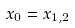Convert formula to latex. <formula><loc_0><loc_0><loc_500><loc_500>x _ { 0 } = x _ { 1 , 2 }</formula> 